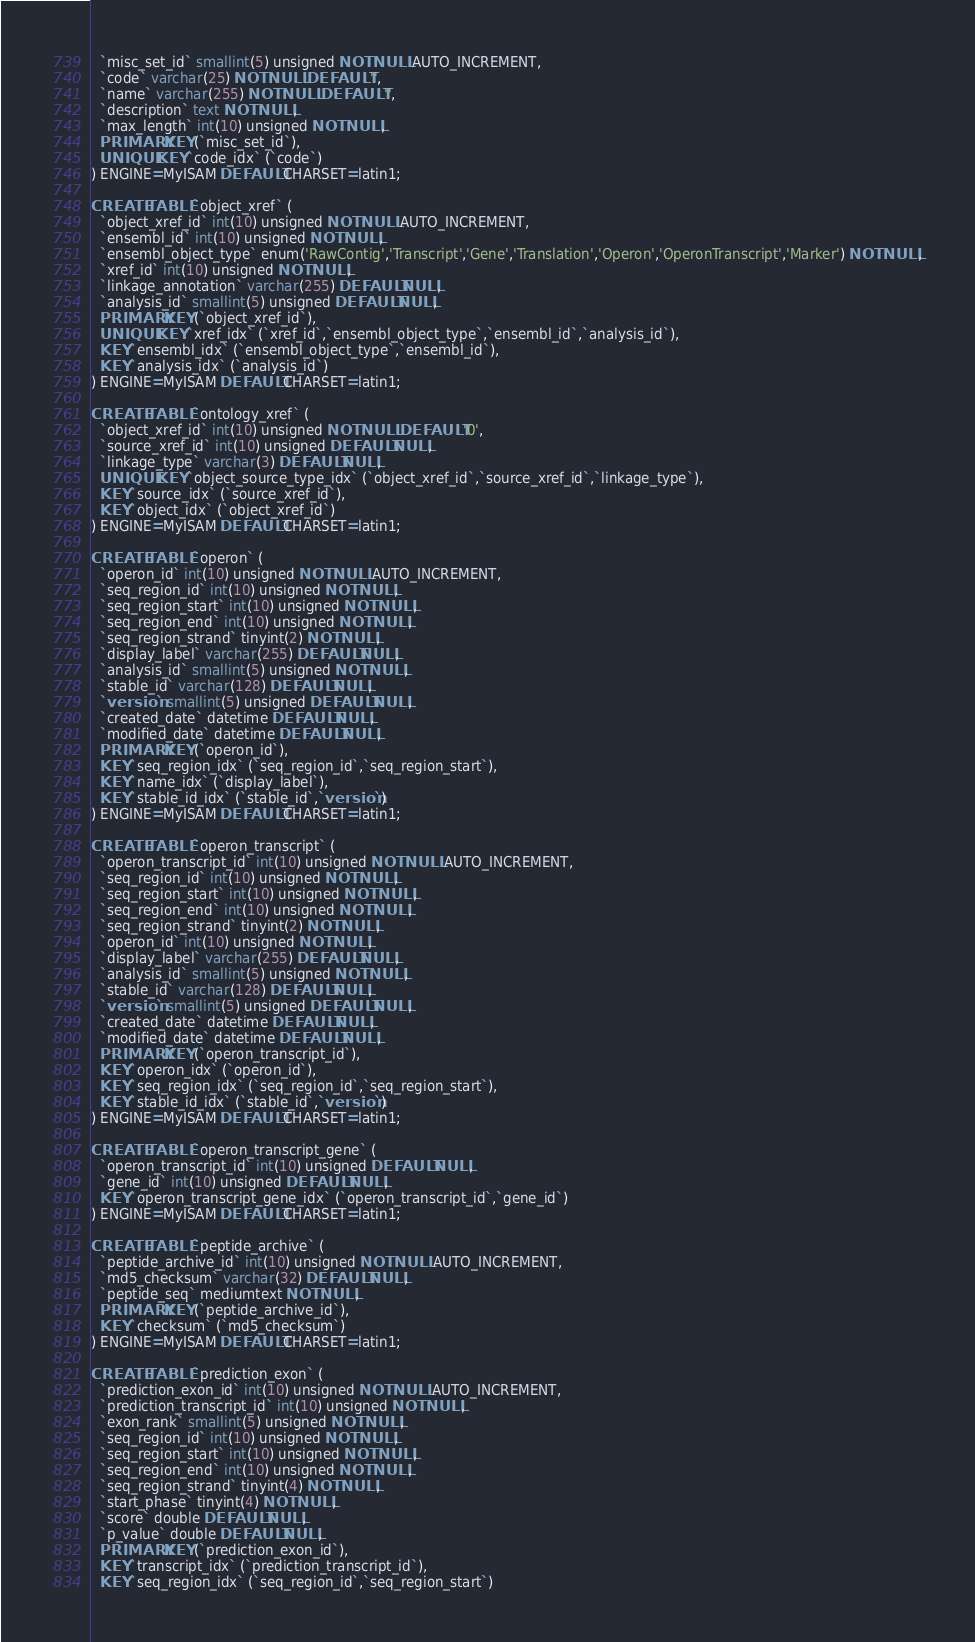<code> <loc_0><loc_0><loc_500><loc_500><_SQL_>  `misc_set_id` smallint(5) unsigned NOT NULL AUTO_INCREMENT,
  `code` varchar(25) NOT NULL DEFAULT '',
  `name` varchar(255) NOT NULL DEFAULT '',
  `description` text NOT NULL,
  `max_length` int(10) unsigned NOT NULL,
  PRIMARY KEY (`misc_set_id`),
  UNIQUE KEY `code_idx` (`code`)
) ENGINE=MyISAM DEFAULT CHARSET=latin1;

CREATE TABLE `object_xref` (
  `object_xref_id` int(10) unsigned NOT NULL AUTO_INCREMENT,
  `ensembl_id` int(10) unsigned NOT NULL,
  `ensembl_object_type` enum('RawContig','Transcript','Gene','Translation','Operon','OperonTranscript','Marker') NOT NULL,
  `xref_id` int(10) unsigned NOT NULL,
  `linkage_annotation` varchar(255) DEFAULT NULL,
  `analysis_id` smallint(5) unsigned DEFAULT NULL,
  PRIMARY KEY (`object_xref_id`),
  UNIQUE KEY `xref_idx` (`xref_id`,`ensembl_object_type`,`ensembl_id`,`analysis_id`),
  KEY `ensembl_idx` (`ensembl_object_type`,`ensembl_id`),
  KEY `analysis_idx` (`analysis_id`)
) ENGINE=MyISAM DEFAULT CHARSET=latin1;

CREATE TABLE `ontology_xref` (
  `object_xref_id` int(10) unsigned NOT NULL DEFAULT '0',
  `source_xref_id` int(10) unsigned DEFAULT NULL,
  `linkage_type` varchar(3) DEFAULT NULL,
  UNIQUE KEY `object_source_type_idx` (`object_xref_id`,`source_xref_id`,`linkage_type`),
  KEY `source_idx` (`source_xref_id`),
  KEY `object_idx` (`object_xref_id`)
) ENGINE=MyISAM DEFAULT CHARSET=latin1;

CREATE TABLE `operon` (
  `operon_id` int(10) unsigned NOT NULL AUTO_INCREMENT,
  `seq_region_id` int(10) unsigned NOT NULL,
  `seq_region_start` int(10) unsigned NOT NULL,
  `seq_region_end` int(10) unsigned NOT NULL,
  `seq_region_strand` tinyint(2) NOT NULL,
  `display_label` varchar(255) DEFAULT NULL,
  `analysis_id` smallint(5) unsigned NOT NULL,
  `stable_id` varchar(128) DEFAULT NULL,
  `version` smallint(5) unsigned DEFAULT NULL,
  `created_date` datetime DEFAULT NULL,
  `modified_date` datetime DEFAULT NULL,
  PRIMARY KEY (`operon_id`),
  KEY `seq_region_idx` (`seq_region_id`,`seq_region_start`),
  KEY `name_idx` (`display_label`),
  KEY `stable_id_idx` (`stable_id`,`version`)
) ENGINE=MyISAM DEFAULT CHARSET=latin1;

CREATE TABLE `operon_transcript` (
  `operon_transcript_id` int(10) unsigned NOT NULL AUTO_INCREMENT,
  `seq_region_id` int(10) unsigned NOT NULL,
  `seq_region_start` int(10) unsigned NOT NULL,
  `seq_region_end` int(10) unsigned NOT NULL,
  `seq_region_strand` tinyint(2) NOT NULL,
  `operon_id` int(10) unsigned NOT NULL,
  `display_label` varchar(255) DEFAULT NULL,
  `analysis_id` smallint(5) unsigned NOT NULL,
  `stable_id` varchar(128) DEFAULT NULL,
  `version` smallint(5) unsigned DEFAULT NULL,
  `created_date` datetime DEFAULT NULL,
  `modified_date` datetime DEFAULT NULL,
  PRIMARY KEY (`operon_transcript_id`),
  KEY `operon_idx` (`operon_id`),
  KEY `seq_region_idx` (`seq_region_id`,`seq_region_start`),
  KEY `stable_id_idx` (`stable_id`,`version`)
) ENGINE=MyISAM DEFAULT CHARSET=latin1;

CREATE TABLE `operon_transcript_gene` (
  `operon_transcript_id` int(10) unsigned DEFAULT NULL,
  `gene_id` int(10) unsigned DEFAULT NULL,
  KEY `operon_transcript_gene_idx` (`operon_transcript_id`,`gene_id`)
) ENGINE=MyISAM DEFAULT CHARSET=latin1;

CREATE TABLE `peptide_archive` (
  `peptide_archive_id` int(10) unsigned NOT NULL AUTO_INCREMENT,
  `md5_checksum` varchar(32) DEFAULT NULL,
  `peptide_seq` mediumtext NOT NULL,
  PRIMARY KEY (`peptide_archive_id`),
  KEY `checksum` (`md5_checksum`)
) ENGINE=MyISAM DEFAULT CHARSET=latin1;

CREATE TABLE `prediction_exon` (
  `prediction_exon_id` int(10) unsigned NOT NULL AUTO_INCREMENT,
  `prediction_transcript_id` int(10) unsigned NOT NULL,
  `exon_rank` smallint(5) unsigned NOT NULL,
  `seq_region_id` int(10) unsigned NOT NULL,
  `seq_region_start` int(10) unsigned NOT NULL,
  `seq_region_end` int(10) unsigned NOT NULL,
  `seq_region_strand` tinyint(4) NOT NULL,
  `start_phase` tinyint(4) NOT NULL,
  `score` double DEFAULT NULL,
  `p_value` double DEFAULT NULL,
  PRIMARY KEY (`prediction_exon_id`),
  KEY `transcript_idx` (`prediction_transcript_id`),
  KEY `seq_region_idx` (`seq_region_id`,`seq_region_start`)</code> 